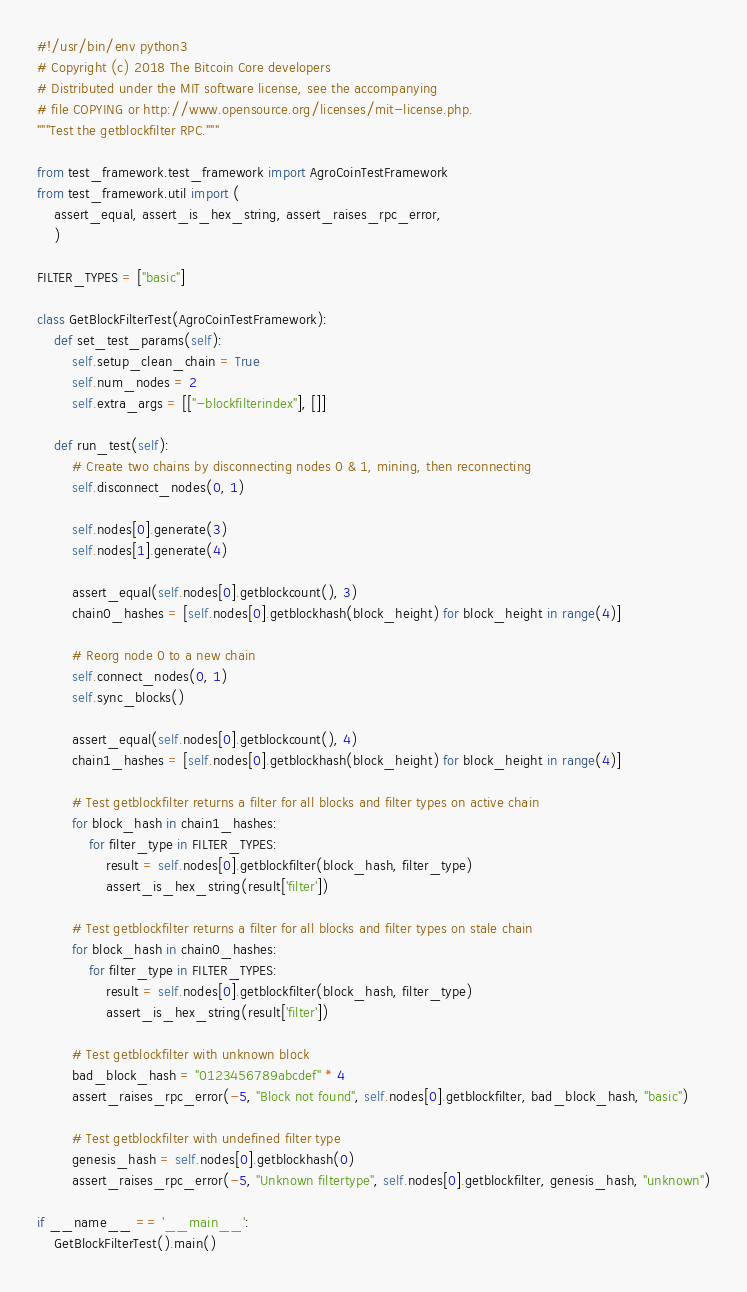<code> <loc_0><loc_0><loc_500><loc_500><_Python_>#!/usr/bin/env python3
# Copyright (c) 2018 The Bitcoin Core developers
# Distributed under the MIT software license, see the accompanying
# file COPYING or http://www.opensource.org/licenses/mit-license.php.
"""Test the getblockfilter RPC."""

from test_framework.test_framework import AgroCoinTestFramework
from test_framework.util import (
    assert_equal, assert_is_hex_string, assert_raises_rpc_error,
    )

FILTER_TYPES = ["basic"]

class GetBlockFilterTest(AgroCoinTestFramework):
    def set_test_params(self):
        self.setup_clean_chain = True
        self.num_nodes = 2
        self.extra_args = [["-blockfilterindex"], []]

    def run_test(self):
        # Create two chains by disconnecting nodes 0 & 1, mining, then reconnecting
        self.disconnect_nodes(0, 1)

        self.nodes[0].generate(3)
        self.nodes[1].generate(4)

        assert_equal(self.nodes[0].getblockcount(), 3)
        chain0_hashes = [self.nodes[0].getblockhash(block_height) for block_height in range(4)]

        # Reorg node 0 to a new chain
        self.connect_nodes(0, 1)
        self.sync_blocks()

        assert_equal(self.nodes[0].getblockcount(), 4)
        chain1_hashes = [self.nodes[0].getblockhash(block_height) for block_height in range(4)]

        # Test getblockfilter returns a filter for all blocks and filter types on active chain
        for block_hash in chain1_hashes:
            for filter_type in FILTER_TYPES:
                result = self.nodes[0].getblockfilter(block_hash, filter_type)
                assert_is_hex_string(result['filter'])

        # Test getblockfilter returns a filter for all blocks and filter types on stale chain
        for block_hash in chain0_hashes:
            for filter_type in FILTER_TYPES:
                result = self.nodes[0].getblockfilter(block_hash, filter_type)
                assert_is_hex_string(result['filter'])

        # Test getblockfilter with unknown block
        bad_block_hash = "0123456789abcdef" * 4
        assert_raises_rpc_error(-5, "Block not found", self.nodes[0].getblockfilter, bad_block_hash, "basic")

        # Test getblockfilter with undefined filter type
        genesis_hash = self.nodes[0].getblockhash(0)
        assert_raises_rpc_error(-5, "Unknown filtertype", self.nodes[0].getblockfilter, genesis_hash, "unknown")

if __name__ == '__main__':
    GetBlockFilterTest().main()
</code> 